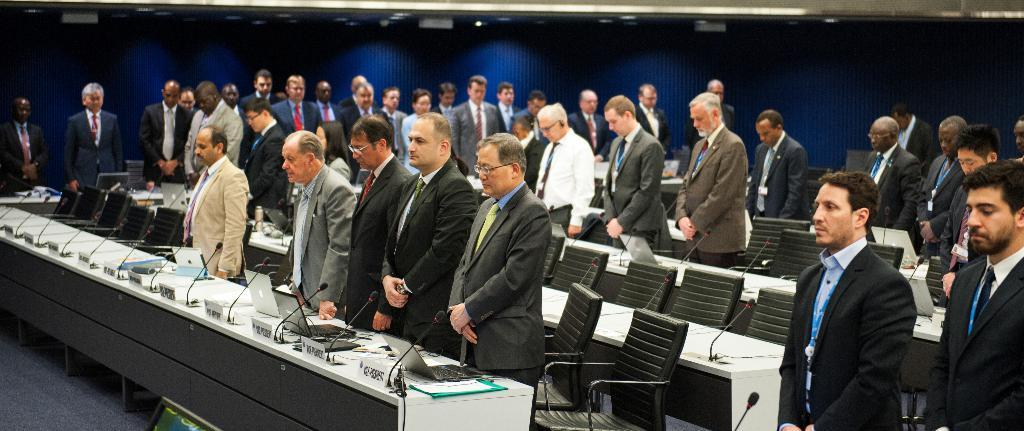What are the people standing near in the image? The people are standing near a table in the image. What objects can be seen on the table? There are laptops, microphones, and boards with text on the table. What might be used for sitting near the table? There are chairs near the table. What is the color of the background in the image? The background of the image is dark. What direction is the territory expanding in the image? There is no territory present in the image, so it is not possible to determine the direction of expansion. How does the anger of the people near the table manifest in the image? There is no indication of anger in the image; the people are standing near the table with laptops, microphones, and boards with text. 